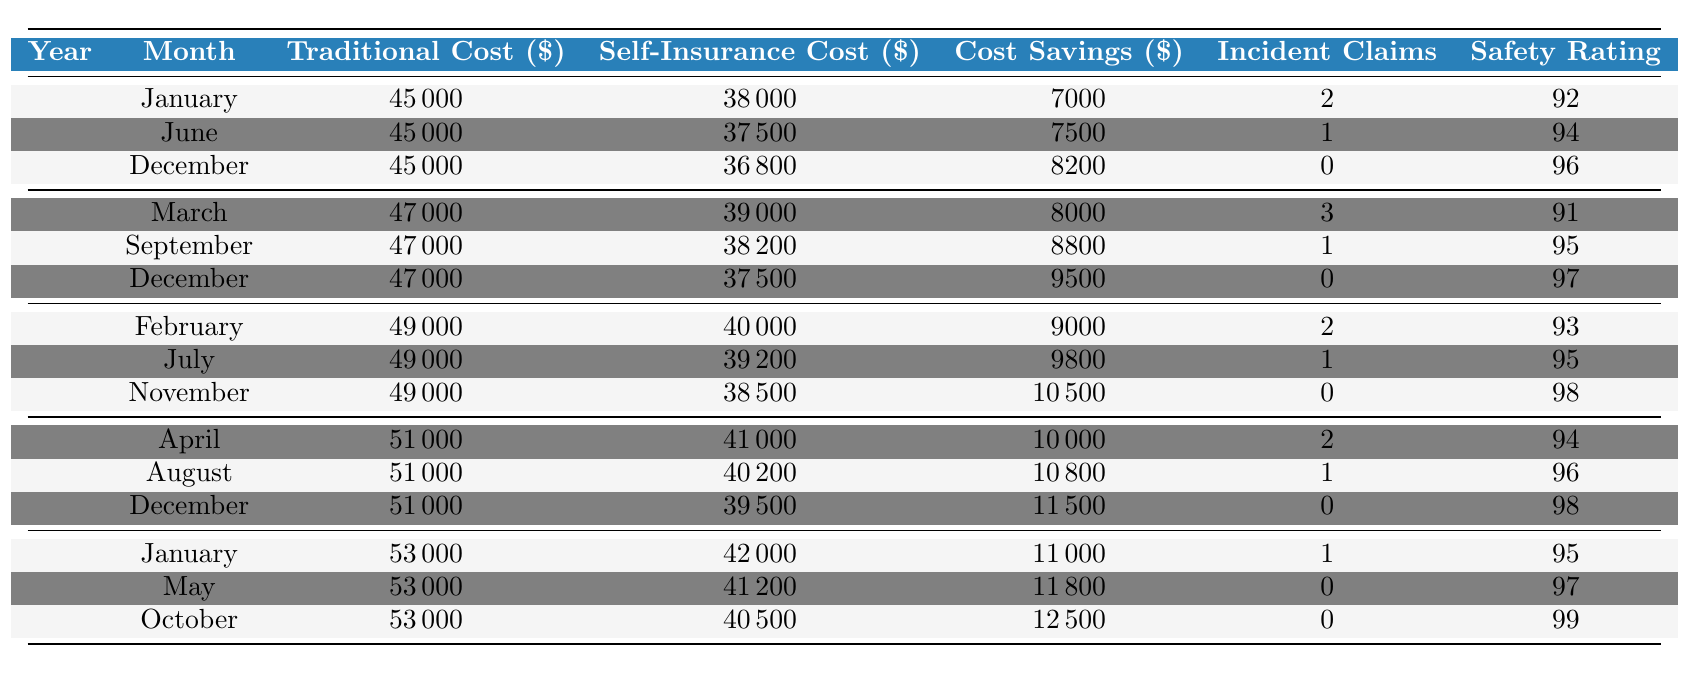What was the traditional insurance cost in March 2020? The table shows that in March 2020, the traditional insurance cost was 47,000.
Answer: 47,000 What is the self-insurance cost for August 2022? According to the table, the self-insurance cost in August 2022 is 40,200.
Answer: 40,200 Which month in 2021 had the highest cost savings? In November 2021, the cost savings were 10,500, which is the highest in that year.
Answer: 10,500 What are the total incident claims reported in 2022? The total incident claims in 2022 can be calculated by adding the claims reported in each month: 2 (April) + 1 (August) + 0 (December) = 3.
Answer: 3 Did the safety rating improve over the years? Comparing the average safety ratings, it can be noted that the ratings generally increased from 92 in 2019 to 99 in 2023, indicating an overall improvement.
Answer: Yes What is the average cost savings across all months? To find the average cost savings, sum all the monthly cost savings: 7,000 + 7,500 + 8,200 + 8,000 + 8,800 + 9,500 + 9,000 + 9,800 + 10,500 + 10,000 + 10,800 + 11,500 + 11,000 + 11,800 + 12,500 = 150,100. Then divide by the number of months (15) to get the average: 150,100 / 15 = 10,006.67.
Answer: 10,006.67 What months in 2020 had cost savings higher than 8,000? In 2020, the months with cost savings higher than 8,000 were September (8,800) and December (9,500).
Answer: September, December In which month did the highest traditional insurance cost occur? The table shows that the highest traditional insurance cost occurred in January 2023, which was 53,000.
Answer: January 2023 What is the difference in safety ratings between the highest and lowest months? The highest safety rating was 99 in October 2023, and the lowest was 91 in March 2020. The difference is 99 - 91 = 8.
Answer: 8 In which year was the total cost savings the largest? By calculating the total cost savings for each year: 2019 (24,700), 2020 (24,300), 2021 (28,300), 2022 (32,300), 2023 (38,300), the largest total cost savings occurred in 2023.
Answer: 2023 Is there a trend in cost savings as the years progress? Analyzing the data, we see that cost savings generally increased from 2019 to 2023, showing a positive trend over the years.
Answer: Yes 